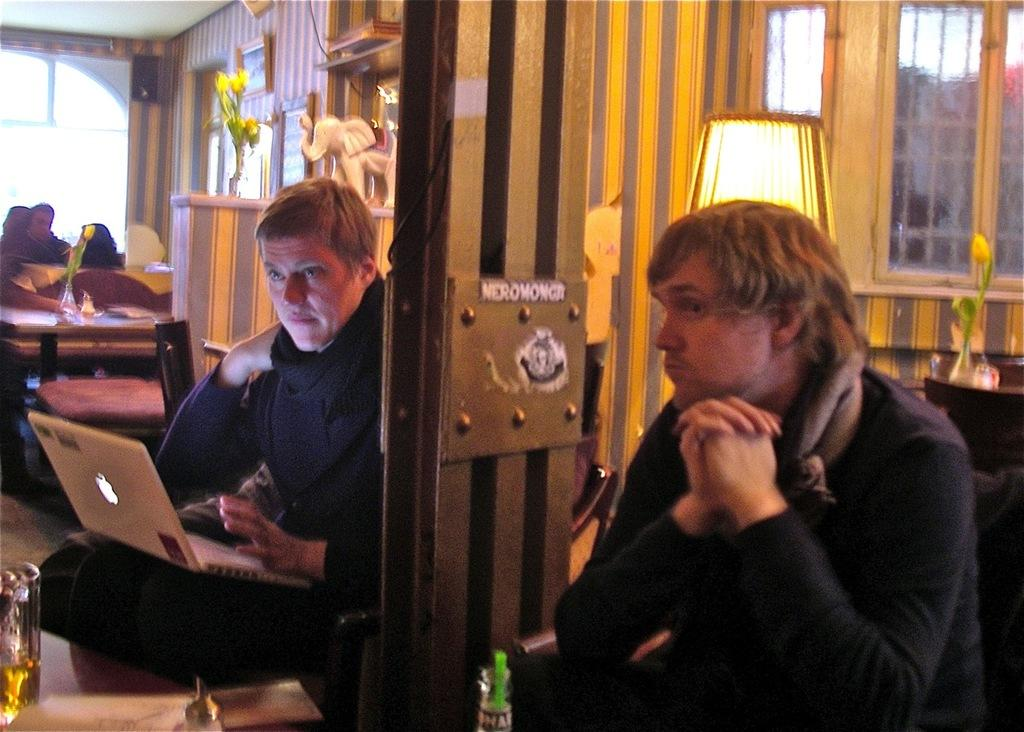How many people are in the image? There are two persons sitting on chairs in the image. What can be seen in the background of the image? There is a wall in the background of the image. Is there any opening in the wall visible in the image? Yes, there is a window in the image. What type of dirt can be seen on the window in the image? There is no dirt visible on the window in the image. How many adjustments were made to the chair design before the final version in the image? The provided facts do not mention any chair design adjustments, so it cannot be determined from the image. 